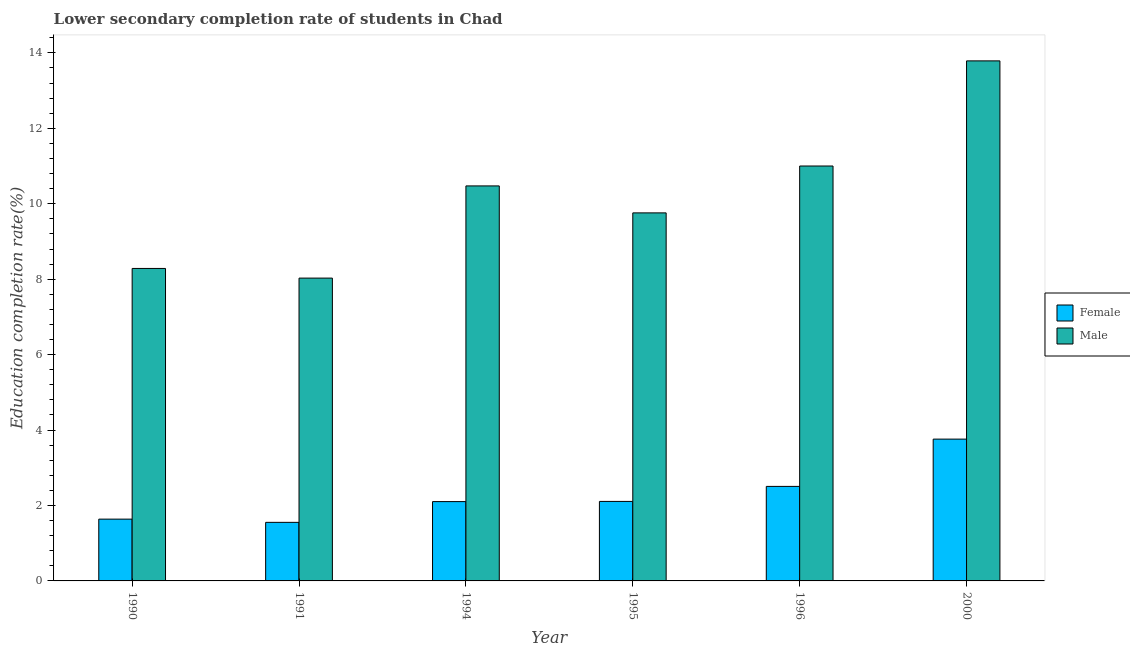How many different coloured bars are there?
Make the answer very short. 2. Are the number of bars per tick equal to the number of legend labels?
Offer a terse response. Yes. Are the number of bars on each tick of the X-axis equal?
Offer a very short reply. Yes. In how many cases, is the number of bars for a given year not equal to the number of legend labels?
Keep it short and to the point. 0. What is the education completion rate of female students in 1994?
Your answer should be compact. 2.1. Across all years, what is the maximum education completion rate of male students?
Provide a short and direct response. 13.79. Across all years, what is the minimum education completion rate of male students?
Keep it short and to the point. 8.03. What is the total education completion rate of female students in the graph?
Your answer should be very brief. 13.67. What is the difference between the education completion rate of male students in 1990 and that in 1991?
Make the answer very short. 0.26. What is the difference between the education completion rate of female students in 1995 and the education completion rate of male students in 1996?
Your answer should be compact. -0.4. What is the average education completion rate of female students per year?
Your answer should be very brief. 2.28. In the year 1990, what is the difference between the education completion rate of male students and education completion rate of female students?
Offer a very short reply. 0. In how many years, is the education completion rate of male students greater than 3.2 %?
Provide a succinct answer. 6. What is the ratio of the education completion rate of female students in 1995 to that in 2000?
Offer a terse response. 0.56. Is the education completion rate of female students in 1990 less than that in 2000?
Provide a succinct answer. Yes. What is the difference between the highest and the second highest education completion rate of male students?
Your answer should be very brief. 2.79. What is the difference between the highest and the lowest education completion rate of female students?
Your answer should be very brief. 2.21. Is the sum of the education completion rate of male students in 1991 and 1994 greater than the maximum education completion rate of female students across all years?
Provide a succinct answer. Yes. What does the 2nd bar from the right in 1995 represents?
Keep it short and to the point. Female. Are the values on the major ticks of Y-axis written in scientific E-notation?
Ensure brevity in your answer.  No. What is the title of the graph?
Make the answer very short. Lower secondary completion rate of students in Chad. Does "Time to export" appear as one of the legend labels in the graph?
Your answer should be very brief. No. What is the label or title of the Y-axis?
Give a very brief answer. Education completion rate(%). What is the Education completion rate(%) of Female in 1990?
Keep it short and to the point. 1.64. What is the Education completion rate(%) in Male in 1990?
Your answer should be very brief. 8.28. What is the Education completion rate(%) of Female in 1991?
Your answer should be compact. 1.55. What is the Education completion rate(%) of Male in 1991?
Ensure brevity in your answer.  8.03. What is the Education completion rate(%) of Female in 1994?
Your answer should be very brief. 2.1. What is the Education completion rate(%) in Male in 1994?
Your response must be concise. 10.47. What is the Education completion rate(%) in Female in 1995?
Your answer should be compact. 2.11. What is the Education completion rate(%) of Male in 1995?
Your answer should be very brief. 9.76. What is the Education completion rate(%) in Female in 1996?
Keep it short and to the point. 2.51. What is the Education completion rate(%) of Male in 1996?
Provide a short and direct response. 11. What is the Education completion rate(%) in Female in 2000?
Give a very brief answer. 3.76. What is the Education completion rate(%) of Male in 2000?
Your answer should be very brief. 13.79. Across all years, what is the maximum Education completion rate(%) in Female?
Offer a very short reply. 3.76. Across all years, what is the maximum Education completion rate(%) of Male?
Keep it short and to the point. 13.79. Across all years, what is the minimum Education completion rate(%) in Female?
Make the answer very short. 1.55. Across all years, what is the minimum Education completion rate(%) in Male?
Ensure brevity in your answer.  8.03. What is the total Education completion rate(%) in Female in the graph?
Provide a succinct answer. 13.67. What is the total Education completion rate(%) in Male in the graph?
Your answer should be very brief. 61.33. What is the difference between the Education completion rate(%) of Female in 1990 and that in 1991?
Provide a succinct answer. 0.09. What is the difference between the Education completion rate(%) in Male in 1990 and that in 1991?
Your answer should be very brief. 0.26. What is the difference between the Education completion rate(%) in Female in 1990 and that in 1994?
Offer a terse response. -0.46. What is the difference between the Education completion rate(%) of Male in 1990 and that in 1994?
Give a very brief answer. -2.19. What is the difference between the Education completion rate(%) of Female in 1990 and that in 1995?
Make the answer very short. -0.47. What is the difference between the Education completion rate(%) in Male in 1990 and that in 1995?
Provide a succinct answer. -1.47. What is the difference between the Education completion rate(%) in Female in 1990 and that in 1996?
Ensure brevity in your answer.  -0.87. What is the difference between the Education completion rate(%) in Male in 1990 and that in 1996?
Your answer should be compact. -2.72. What is the difference between the Education completion rate(%) in Female in 1990 and that in 2000?
Offer a terse response. -2.12. What is the difference between the Education completion rate(%) of Male in 1990 and that in 2000?
Ensure brevity in your answer.  -5.5. What is the difference between the Education completion rate(%) in Female in 1991 and that in 1994?
Offer a terse response. -0.55. What is the difference between the Education completion rate(%) in Male in 1991 and that in 1994?
Ensure brevity in your answer.  -2.44. What is the difference between the Education completion rate(%) in Female in 1991 and that in 1995?
Your answer should be very brief. -0.56. What is the difference between the Education completion rate(%) of Male in 1991 and that in 1995?
Make the answer very short. -1.73. What is the difference between the Education completion rate(%) of Female in 1991 and that in 1996?
Keep it short and to the point. -0.95. What is the difference between the Education completion rate(%) in Male in 1991 and that in 1996?
Keep it short and to the point. -2.97. What is the difference between the Education completion rate(%) in Female in 1991 and that in 2000?
Keep it short and to the point. -2.21. What is the difference between the Education completion rate(%) in Male in 1991 and that in 2000?
Your response must be concise. -5.76. What is the difference between the Education completion rate(%) of Female in 1994 and that in 1995?
Make the answer very short. -0. What is the difference between the Education completion rate(%) in Male in 1994 and that in 1995?
Provide a short and direct response. 0.71. What is the difference between the Education completion rate(%) in Female in 1994 and that in 1996?
Your answer should be very brief. -0.4. What is the difference between the Education completion rate(%) in Male in 1994 and that in 1996?
Ensure brevity in your answer.  -0.53. What is the difference between the Education completion rate(%) in Female in 1994 and that in 2000?
Keep it short and to the point. -1.66. What is the difference between the Education completion rate(%) of Male in 1994 and that in 2000?
Make the answer very short. -3.32. What is the difference between the Education completion rate(%) of Female in 1995 and that in 1996?
Your answer should be very brief. -0.4. What is the difference between the Education completion rate(%) of Male in 1995 and that in 1996?
Offer a very short reply. -1.24. What is the difference between the Education completion rate(%) in Female in 1995 and that in 2000?
Ensure brevity in your answer.  -1.65. What is the difference between the Education completion rate(%) of Male in 1995 and that in 2000?
Make the answer very short. -4.03. What is the difference between the Education completion rate(%) of Female in 1996 and that in 2000?
Keep it short and to the point. -1.25. What is the difference between the Education completion rate(%) of Male in 1996 and that in 2000?
Your response must be concise. -2.79. What is the difference between the Education completion rate(%) in Female in 1990 and the Education completion rate(%) in Male in 1991?
Offer a very short reply. -6.39. What is the difference between the Education completion rate(%) of Female in 1990 and the Education completion rate(%) of Male in 1994?
Offer a terse response. -8.83. What is the difference between the Education completion rate(%) in Female in 1990 and the Education completion rate(%) in Male in 1995?
Ensure brevity in your answer.  -8.12. What is the difference between the Education completion rate(%) in Female in 1990 and the Education completion rate(%) in Male in 1996?
Ensure brevity in your answer.  -9.36. What is the difference between the Education completion rate(%) in Female in 1990 and the Education completion rate(%) in Male in 2000?
Ensure brevity in your answer.  -12.15. What is the difference between the Education completion rate(%) in Female in 1991 and the Education completion rate(%) in Male in 1994?
Your answer should be compact. -8.92. What is the difference between the Education completion rate(%) in Female in 1991 and the Education completion rate(%) in Male in 1995?
Ensure brevity in your answer.  -8.21. What is the difference between the Education completion rate(%) of Female in 1991 and the Education completion rate(%) of Male in 1996?
Your answer should be very brief. -9.45. What is the difference between the Education completion rate(%) in Female in 1991 and the Education completion rate(%) in Male in 2000?
Your answer should be very brief. -12.24. What is the difference between the Education completion rate(%) of Female in 1994 and the Education completion rate(%) of Male in 1995?
Give a very brief answer. -7.65. What is the difference between the Education completion rate(%) in Female in 1994 and the Education completion rate(%) in Male in 1996?
Provide a short and direct response. -8.9. What is the difference between the Education completion rate(%) of Female in 1994 and the Education completion rate(%) of Male in 2000?
Your answer should be very brief. -11.68. What is the difference between the Education completion rate(%) of Female in 1995 and the Education completion rate(%) of Male in 1996?
Make the answer very short. -8.89. What is the difference between the Education completion rate(%) of Female in 1995 and the Education completion rate(%) of Male in 2000?
Provide a succinct answer. -11.68. What is the difference between the Education completion rate(%) in Female in 1996 and the Education completion rate(%) in Male in 2000?
Offer a terse response. -11.28. What is the average Education completion rate(%) in Female per year?
Ensure brevity in your answer.  2.28. What is the average Education completion rate(%) of Male per year?
Provide a succinct answer. 10.22. In the year 1990, what is the difference between the Education completion rate(%) of Female and Education completion rate(%) of Male?
Keep it short and to the point. -6.65. In the year 1991, what is the difference between the Education completion rate(%) in Female and Education completion rate(%) in Male?
Your answer should be compact. -6.48. In the year 1994, what is the difference between the Education completion rate(%) in Female and Education completion rate(%) in Male?
Offer a very short reply. -8.37. In the year 1995, what is the difference between the Education completion rate(%) in Female and Education completion rate(%) in Male?
Your answer should be very brief. -7.65. In the year 1996, what is the difference between the Education completion rate(%) of Female and Education completion rate(%) of Male?
Give a very brief answer. -8.49. In the year 2000, what is the difference between the Education completion rate(%) of Female and Education completion rate(%) of Male?
Offer a very short reply. -10.03. What is the ratio of the Education completion rate(%) in Female in 1990 to that in 1991?
Your response must be concise. 1.06. What is the ratio of the Education completion rate(%) in Male in 1990 to that in 1991?
Provide a succinct answer. 1.03. What is the ratio of the Education completion rate(%) in Female in 1990 to that in 1994?
Provide a succinct answer. 0.78. What is the ratio of the Education completion rate(%) of Male in 1990 to that in 1994?
Give a very brief answer. 0.79. What is the ratio of the Education completion rate(%) of Female in 1990 to that in 1995?
Offer a very short reply. 0.78. What is the ratio of the Education completion rate(%) in Male in 1990 to that in 1995?
Ensure brevity in your answer.  0.85. What is the ratio of the Education completion rate(%) in Female in 1990 to that in 1996?
Your answer should be very brief. 0.65. What is the ratio of the Education completion rate(%) of Male in 1990 to that in 1996?
Your answer should be compact. 0.75. What is the ratio of the Education completion rate(%) in Female in 1990 to that in 2000?
Offer a terse response. 0.44. What is the ratio of the Education completion rate(%) of Male in 1990 to that in 2000?
Provide a short and direct response. 0.6. What is the ratio of the Education completion rate(%) of Female in 1991 to that in 1994?
Offer a very short reply. 0.74. What is the ratio of the Education completion rate(%) in Male in 1991 to that in 1994?
Ensure brevity in your answer.  0.77. What is the ratio of the Education completion rate(%) in Female in 1991 to that in 1995?
Keep it short and to the point. 0.74. What is the ratio of the Education completion rate(%) of Male in 1991 to that in 1995?
Offer a terse response. 0.82. What is the ratio of the Education completion rate(%) in Female in 1991 to that in 1996?
Keep it short and to the point. 0.62. What is the ratio of the Education completion rate(%) in Male in 1991 to that in 1996?
Your answer should be compact. 0.73. What is the ratio of the Education completion rate(%) in Female in 1991 to that in 2000?
Your answer should be compact. 0.41. What is the ratio of the Education completion rate(%) of Male in 1991 to that in 2000?
Your response must be concise. 0.58. What is the ratio of the Education completion rate(%) in Female in 1994 to that in 1995?
Your answer should be very brief. 1. What is the ratio of the Education completion rate(%) in Male in 1994 to that in 1995?
Your answer should be compact. 1.07. What is the ratio of the Education completion rate(%) in Female in 1994 to that in 1996?
Provide a short and direct response. 0.84. What is the ratio of the Education completion rate(%) in Male in 1994 to that in 1996?
Your answer should be compact. 0.95. What is the ratio of the Education completion rate(%) in Female in 1994 to that in 2000?
Offer a terse response. 0.56. What is the ratio of the Education completion rate(%) in Male in 1994 to that in 2000?
Keep it short and to the point. 0.76. What is the ratio of the Education completion rate(%) in Female in 1995 to that in 1996?
Provide a succinct answer. 0.84. What is the ratio of the Education completion rate(%) in Male in 1995 to that in 1996?
Offer a very short reply. 0.89. What is the ratio of the Education completion rate(%) of Female in 1995 to that in 2000?
Offer a very short reply. 0.56. What is the ratio of the Education completion rate(%) of Male in 1995 to that in 2000?
Your response must be concise. 0.71. What is the ratio of the Education completion rate(%) in Female in 1996 to that in 2000?
Make the answer very short. 0.67. What is the ratio of the Education completion rate(%) of Male in 1996 to that in 2000?
Offer a very short reply. 0.8. What is the difference between the highest and the second highest Education completion rate(%) of Female?
Your response must be concise. 1.25. What is the difference between the highest and the second highest Education completion rate(%) in Male?
Offer a very short reply. 2.79. What is the difference between the highest and the lowest Education completion rate(%) in Female?
Provide a succinct answer. 2.21. What is the difference between the highest and the lowest Education completion rate(%) of Male?
Your answer should be compact. 5.76. 